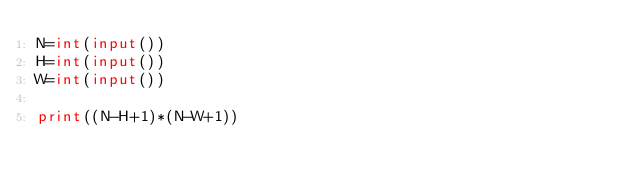Convert code to text. <code><loc_0><loc_0><loc_500><loc_500><_Python_>N=int(input())
H=int(input())
W=int(input())

print((N-H+1)*(N-W+1))</code> 